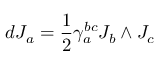<formula> <loc_0><loc_0><loc_500><loc_500>d J _ { a } = { \frac { 1 } { 2 } } \gamma _ { a } ^ { b c } J _ { b } \wedge J _ { c }</formula> 